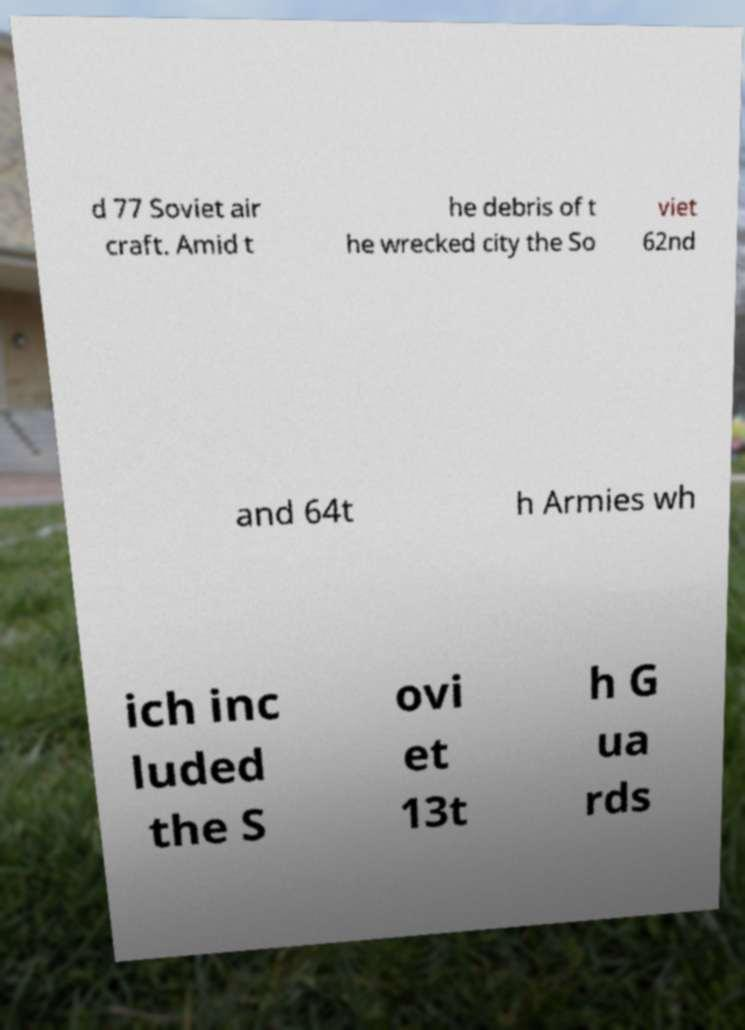Could you assist in decoding the text presented in this image and type it out clearly? d 77 Soviet air craft. Amid t he debris of t he wrecked city the So viet 62nd and 64t h Armies wh ich inc luded the S ovi et 13t h G ua rds 